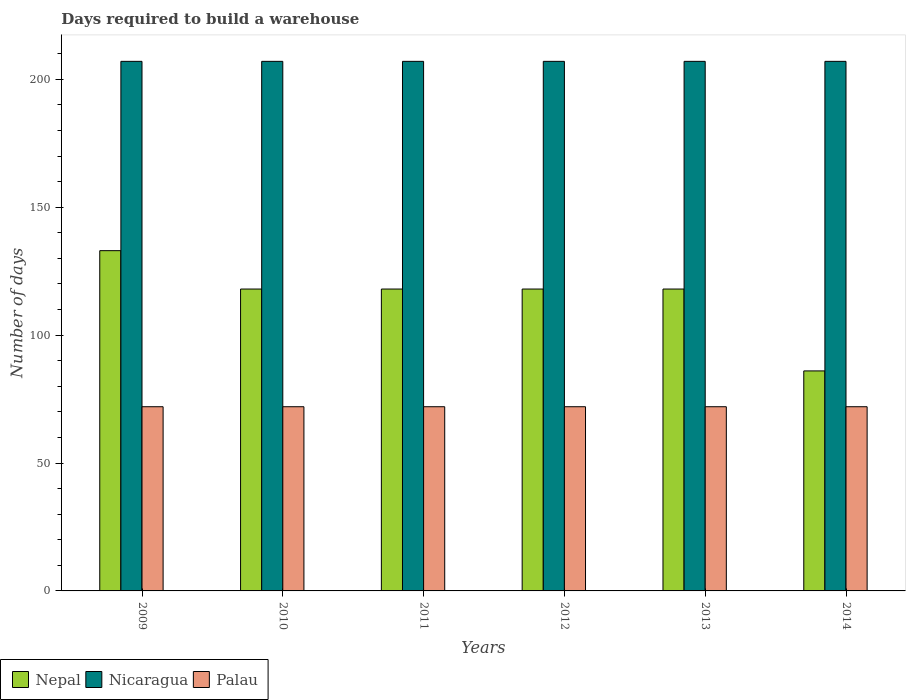Are the number of bars per tick equal to the number of legend labels?
Give a very brief answer. Yes. Are the number of bars on each tick of the X-axis equal?
Your answer should be compact. Yes. What is the days required to build a warehouse in in Nepal in 2009?
Offer a very short reply. 133. Across all years, what is the maximum days required to build a warehouse in in Nicaragua?
Keep it short and to the point. 207. Across all years, what is the minimum days required to build a warehouse in in Palau?
Give a very brief answer. 72. What is the total days required to build a warehouse in in Nepal in the graph?
Your answer should be very brief. 691. What is the difference between the days required to build a warehouse in in Nepal in 2009 and the days required to build a warehouse in in Palau in 2012?
Provide a succinct answer. 61. What is the average days required to build a warehouse in in Nicaragua per year?
Give a very brief answer. 207. In the year 2010, what is the difference between the days required to build a warehouse in in Palau and days required to build a warehouse in in Nicaragua?
Offer a very short reply. -135. In how many years, is the days required to build a warehouse in in Nepal greater than 140 days?
Your answer should be very brief. 0. Is the days required to build a warehouse in in Palau in 2010 less than that in 2013?
Make the answer very short. No. In how many years, is the days required to build a warehouse in in Palau greater than the average days required to build a warehouse in in Palau taken over all years?
Offer a very short reply. 0. What does the 1st bar from the left in 2013 represents?
Provide a succinct answer. Nepal. What does the 1st bar from the right in 2014 represents?
Keep it short and to the point. Palau. Is it the case that in every year, the sum of the days required to build a warehouse in in Nepal and days required to build a warehouse in in Nicaragua is greater than the days required to build a warehouse in in Palau?
Keep it short and to the point. Yes. How many bars are there?
Offer a terse response. 18. Are all the bars in the graph horizontal?
Make the answer very short. No. How many years are there in the graph?
Your response must be concise. 6. Are the values on the major ticks of Y-axis written in scientific E-notation?
Your answer should be compact. No. Does the graph contain grids?
Provide a succinct answer. No. How many legend labels are there?
Give a very brief answer. 3. What is the title of the graph?
Ensure brevity in your answer.  Days required to build a warehouse. Does "Papua New Guinea" appear as one of the legend labels in the graph?
Ensure brevity in your answer.  No. What is the label or title of the Y-axis?
Provide a short and direct response. Number of days. What is the Number of days of Nepal in 2009?
Keep it short and to the point. 133. What is the Number of days of Nicaragua in 2009?
Offer a terse response. 207. What is the Number of days of Nepal in 2010?
Keep it short and to the point. 118. What is the Number of days in Nicaragua in 2010?
Your response must be concise. 207. What is the Number of days in Palau in 2010?
Offer a terse response. 72. What is the Number of days in Nepal in 2011?
Ensure brevity in your answer.  118. What is the Number of days of Nicaragua in 2011?
Your answer should be very brief. 207. What is the Number of days in Nepal in 2012?
Offer a terse response. 118. What is the Number of days in Nicaragua in 2012?
Give a very brief answer. 207. What is the Number of days in Nepal in 2013?
Provide a succinct answer. 118. What is the Number of days in Nicaragua in 2013?
Ensure brevity in your answer.  207. What is the Number of days in Nepal in 2014?
Your answer should be compact. 86. What is the Number of days of Nicaragua in 2014?
Your answer should be compact. 207. Across all years, what is the maximum Number of days in Nepal?
Offer a very short reply. 133. Across all years, what is the maximum Number of days in Nicaragua?
Offer a very short reply. 207. Across all years, what is the maximum Number of days of Palau?
Ensure brevity in your answer.  72. Across all years, what is the minimum Number of days in Nepal?
Ensure brevity in your answer.  86. Across all years, what is the minimum Number of days of Nicaragua?
Your response must be concise. 207. What is the total Number of days of Nepal in the graph?
Your answer should be compact. 691. What is the total Number of days of Nicaragua in the graph?
Provide a succinct answer. 1242. What is the total Number of days in Palau in the graph?
Give a very brief answer. 432. What is the difference between the Number of days of Nepal in 2009 and that in 2010?
Your response must be concise. 15. What is the difference between the Number of days in Palau in 2009 and that in 2010?
Give a very brief answer. 0. What is the difference between the Number of days in Nepal in 2009 and that in 2011?
Your answer should be very brief. 15. What is the difference between the Number of days in Nicaragua in 2009 and that in 2012?
Your answer should be very brief. 0. What is the difference between the Number of days of Palau in 2009 and that in 2013?
Offer a terse response. 0. What is the difference between the Number of days of Nicaragua in 2009 and that in 2014?
Offer a terse response. 0. What is the difference between the Number of days of Palau in 2010 and that in 2012?
Provide a short and direct response. 0. What is the difference between the Number of days in Nepal in 2010 and that in 2013?
Provide a short and direct response. 0. What is the difference between the Number of days in Nicaragua in 2010 and that in 2013?
Give a very brief answer. 0. What is the difference between the Number of days in Nepal in 2011 and that in 2013?
Your response must be concise. 0. What is the difference between the Number of days in Nepal in 2011 and that in 2014?
Provide a short and direct response. 32. What is the difference between the Number of days of Palau in 2011 and that in 2014?
Offer a very short reply. 0. What is the difference between the Number of days in Nepal in 2012 and that in 2013?
Provide a succinct answer. 0. What is the difference between the Number of days of Palau in 2012 and that in 2013?
Offer a very short reply. 0. What is the difference between the Number of days in Nicaragua in 2012 and that in 2014?
Keep it short and to the point. 0. What is the difference between the Number of days of Nicaragua in 2013 and that in 2014?
Make the answer very short. 0. What is the difference between the Number of days of Nepal in 2009 and the Number of days of Nicaragua in 2010?
Give a very brief answer. -74. What is the difference between the Number of days in Nepal in 2009 and the Number of days in Palau in 2010?
Ensure brevity in your answer.  61. What is the difference between the Number of days of Nicaragua in 2009 and the Number of days of Palau in 2010?
Provide a short and direct response. 135. What is the difference between the Number of days of Nepal in 2009 and the Number of days of Nicaragua in 2011?
Make the answer very short. -74. What is the difference between the Number of days of Nepal in 2009 and the Number of days of Palau in 2011?
Give a very brief answer. 61. What is the difference between the Number of days of Nicaragua in 2009 and the Number of days of Palau in 2011?
Your answer should be very brief. 135. What is the difference between the Number of days of Nepal in 2009 and the Number of days of Nicaragua in 2012?
Give a very brief answer. -74. What is the difference between the Number of days of Nicaragua in 2009 and the Number of days of Palau in 2012?
Ensure brevity in your answer.  135. What is the difference between the Number of days of Nepal in 2009 and the Number of days of Nicaragua in 2013?
Make the answer very short. -74. What is the difference between the Number of days of Nepal in 2009 and the Number of days of Palau in 2013?
Offer a terse response. 61. What is the difference between the Number of days in Nicaragua in 2009 and the Number of days in Palau in 2013?
Your answer should be compact. 135. What is the difference between the Number of days of Nepal in 2009 and the Number of days of Nicaragua in 2014?
Ensure brevity in your answer.  -74. What is the difference between the Number of days of Nepal in 2009 and the Number of days of Palau in 2014?
Provide a short and direct response. 61. What is the difference between the Number of days of Nicaragua in 2009 and the Number of days of Palau in 2014?
Keep it short and to the point. 135. What is the difference between the Number of days in Nepal in 2010 and the Number of days in Nicaragua in 2011?
Make the answer very short. -89. What is the difference between the Number of days of Nepal in 2010 and the Number of days of Palau in 2011?
Give a very brief answer. 46. What is the difference between the Number of days of Nicaragua in 2010 and the Number of days of Palau in 2011?
Offer a terse response. 135. What is the difference between the Number of days of Nepal in 2010 and the Number of days of Nicaragua in 2012?
Your response must be concise. -89. What is the difference between the Number of days in Nepal in 2010 and the Number of days in Palau in 2012?
Offer a terse response. 46. What is the difference between the Number of days of Nicaragua in 2010 and the Number of days of Palau in 2012?
Provide a short and direct response. 135. What is the difference between the Number of days in Nepal in 2010 and the Number of days in Nicaragua in 2013?
Ensure brevity in your answer.  -89. What is the difference between the Number of days of Nicaragua in 2010 and the Number of days of Palau in 2013?
Your answer should be very brief. 135. What is the difference between the Number of days in Nepal in 2010 and the Number of days in Nicaragua in 2014?
Your answer should be compact. -89. What is the difference between the Number of days in Nicaragua in 2010 and the Number of days in Palau in 2014?
Offer a terse response. 135. What is the difference between the Number of days in Nepal in 2011 and the Number of days in Nicaragua in 2012?
Your response must be concise. -89. What is the difference between the Number of days in Nicaragua in 2011 and the Number of days in Palau in 2012?
Provide a succinct answer. 135. What is the difference between the Number of days in Nepal in 2011 and the Number of days in Nicaragua in 2013?
Provide a short and direct response. -89. What is the difference between the Number of days of Nepal in 2011 and the Number of days of Palau in 2013?
Provide a short and direct response. 46. What is the difference between the Number of days of Nicaragua in 2011 and the Number of days of Palau in 2013?
Provide a short and direct response. 135. What is the difference between the Number of days in Nepal in 2011 and the Number of days in Nicaragua in 2014?
Provide a succinct answer. -89. What is the difference between the Number of days in Nicaragua in 2011 and the Number of days in Palau in 2014?
Your response must be concise. 135. What is the difference between the Number of days in Nepal in 2012 and the Number of days in Nicaragua in 2013?
Keep it short and to the point. -89. What is the difference between the Number of days in Nicaragua in 2012 and the Number of days in Palau in 2013?
Keep it short and to the point. 135. What is the difference between the Number of days of Nepal in 2012 and the Number of days of Nicaragua in 2014?
Ensure brevity in your answer.  -89. What is the difference between the Number of days in Nicaragua in 2012 and the Number of days in Palau in 2014?
Offer a very short reply. 135. What is the difference between the Number of days in Nepal in 2013 and the Number of days in Nicaragua in 2014?
Ensure brevity in your answer.  -89. What is the difference between the Number of days in Nepal in 2013 and the Number of days in Palau in 2014?
Ensure brevity in your answer.  46. What is the difference between the Number of days of Nicaragua in 2013 and the Number of days of Palau in 2014?
Make the answer very short. 135. What is the average Number of days of Nepal per year?
Give a very brief answer. 115.17. What is the average Number of days in Nicaragua per year?
Your answer should be very brief. 207. What is the average Number of days in Palau per year?
Give a very brief answer. 72. In the year 2009, what is the difference between the Number of days of Nepal and Number of days of Nicaragua?
Provide a short and direct response. -74. In the year 2009, what is the difference between the Number of days of Nicaragua and Number of days of Palau?
Make the answer very short. 135. In the year 2010, what is the difference between the Number of days of Nepal and Number of days of Nicaragua?
Keep it short and to the point. -89. In the year 2010, what is the difference between the Number of days in Nicaragua and Number of days in Palau?
Offer a very short reply. 135. In the year 2011, what is the difference between the Number of days of Nepal and Number of days of Nicaragua?
Your answer should be compact. -89. In the year 2011, what is the difference between the Number of days of Nepal and Number of days of Palau?
Give a very brief answer. 46. In the year 2011, what is the difference between the Number of days of Nicaragua and Number of days of Palau?
Provide a short and direct response. 135. In the year 2012, what is the difference between the Number of days in Nepal and Number of days in Nicaragua?
Your answer should be very brief. -89. In the year 2012, what is the difference between the Number of days in Nicaragua and Number of days in Palau?
Provide a succinct answer. 135. In the year 2013, what is the difference between the Number of days of Nepal and Number of days of Nicaragua?
Your response must be concise. -89. In the year 2013, what is the difference between the Number of days in Nicaragua and Number of days in Palau?
Offer a very short reply. 135. In the year 2014, what is the difference between the Number of days in Nepal and Number of days in Nicaragua?
Your response must be concise. -121. In the year 2014, what is the difference between the Number of days in Nepal and Number of days in Palau?
Offer a terse response. 14. In the year 2014, what is the difference between the Number of days of Nicaragua and Number of days of Palau?
Offer a very short reply. 135. What is the ratio of the Number of days of Nepal in 2009 to that in 2010?
Ensure brevity in your answer.  1.13. What is the ratio of the Number of days in Nepal in 2009 to that in 2011?
Give a very brief answer. 1.13. What is the ratio of the Number of days of Palau in 2009 to that in 2011?
Provide a succinct answer. 1. What is the ratio of the Number of days of Nepal in 2009 to that in 2012?
Provide a succinct answer. 1.13. What is the ratio of the Number of days of Palau in 2009 to that in 2012?
Your answer should be very brief. 1. What is the ratio of the Number of days of Nepal in 2009 to that in 2013?
Your response must be concise. 1.13. What is the ratio of the Number of days of Nepal in 2009 to that in 2014?
Your answer should be compact. 1.55. What is the ratio of the Number of days in Nicaragua in 2009 to that in 2014?
Provide a succinct answer. 1. What is the ratio of the Number of days in Nepal in 2010 to that in 2011?
Ensure brevity in your answer.  1. What is the ratio of the Number of days in Nepal in 2010 to that in 2012?
Your answer should be compact. 1. What is the ratio of the Number of days of Nicaragua in 2010 to that in 2013?
Provide a short and direct response. 1. What is the ratio of the Number of days in Palau in 2010 to that in 2013?
Provide a short and direct response. 1. What is the ratio of the Number of days in Nepal in 2010 to that in 2014?
Give a very brief answer. 1.37. What is the ratio of the Number of days in Nepal in 2011 to that in 2012?
Give a very brief answer. 1. What is the ratio of the Number of days of Nicaragua in 2011 to that in 2012?
Offer a very short reply. 1. What is the ratio of the Number of days of Nepal in 2011 to that in 2014?
Offer a very short reply. 1.37. What is the ratio of the Number of days in Palau in 2011 to that in 2014?
Provide a short and direct response. 1. What is the ratio of the Number of days in Palau in 2012 to that in 2013?
Offer a terse response. 1. What is the ratio of the Number of days of Nepal in 2012 to that in 2014?
Your response must be concise. 1.37. What is the ratio of the Number of days of Nicaragua in 2012 to that in 2014?
Offer a terse response. 1. What is the ratio of the Number of days in Nepal in 2013 to that in 2014?
Your answer should be compact. 1.37. What is the difference between the highest and the second highest Number of days of Nepal?
Make the answer very short. 15. What is the difference between the highest and the second highest Number of days in Palau?
Your answer should be very brief. 0. What is the difference between the highest and the lowest Number of days of Nepal?
Offer a very short reply. 47. What is the difference between the highest and the lowest Number of days of Nicaragua?
Make the answer very short. 0. 